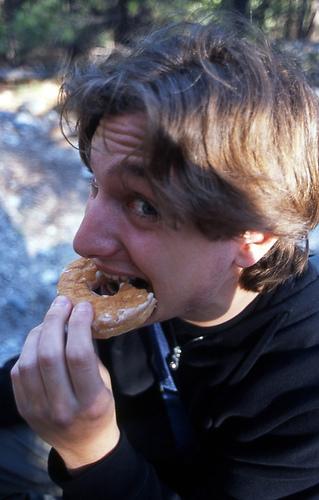Is it sunny?
Be succinct. Yes. Male or female?
Be succinct. Male. Is this a healthy food?
Give a very brief answer. No. 